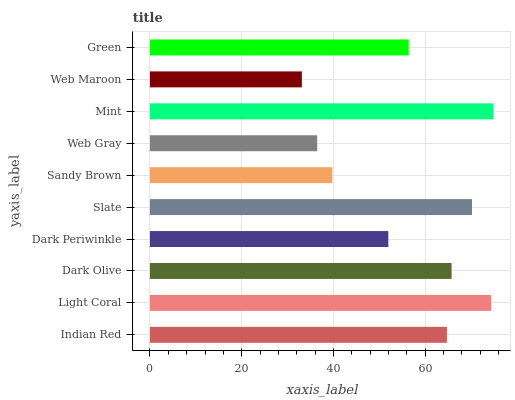Is Web Maroon the minimum?
Answer yes or no. Yes. Is Mint the maximum?
Answer yes or no. Yes. Is Light Coral the minimum?
Answer yes or no. No. Is Light Coral the maximum?
Answer yes or no. No. Is Light Coral greater than Indian Red?
Answer yes or no. Yes. Is Indian Red less than Light Coral?
Answer yes or no. Yes. Is Indian Red greater than Light Coral?
Answer yes or no. No. Is Light Coral less than Indian Red?
Answer yes or no. No. Is Indian Red the high median?
Answer yes or no. Yes. Is Green the low median?
Answer yes or no. Yes. Is Sandy Brown the high median?
Answer yes or no. No. Is Dark Periwinkle the low median?
Answer yes or no. No. 